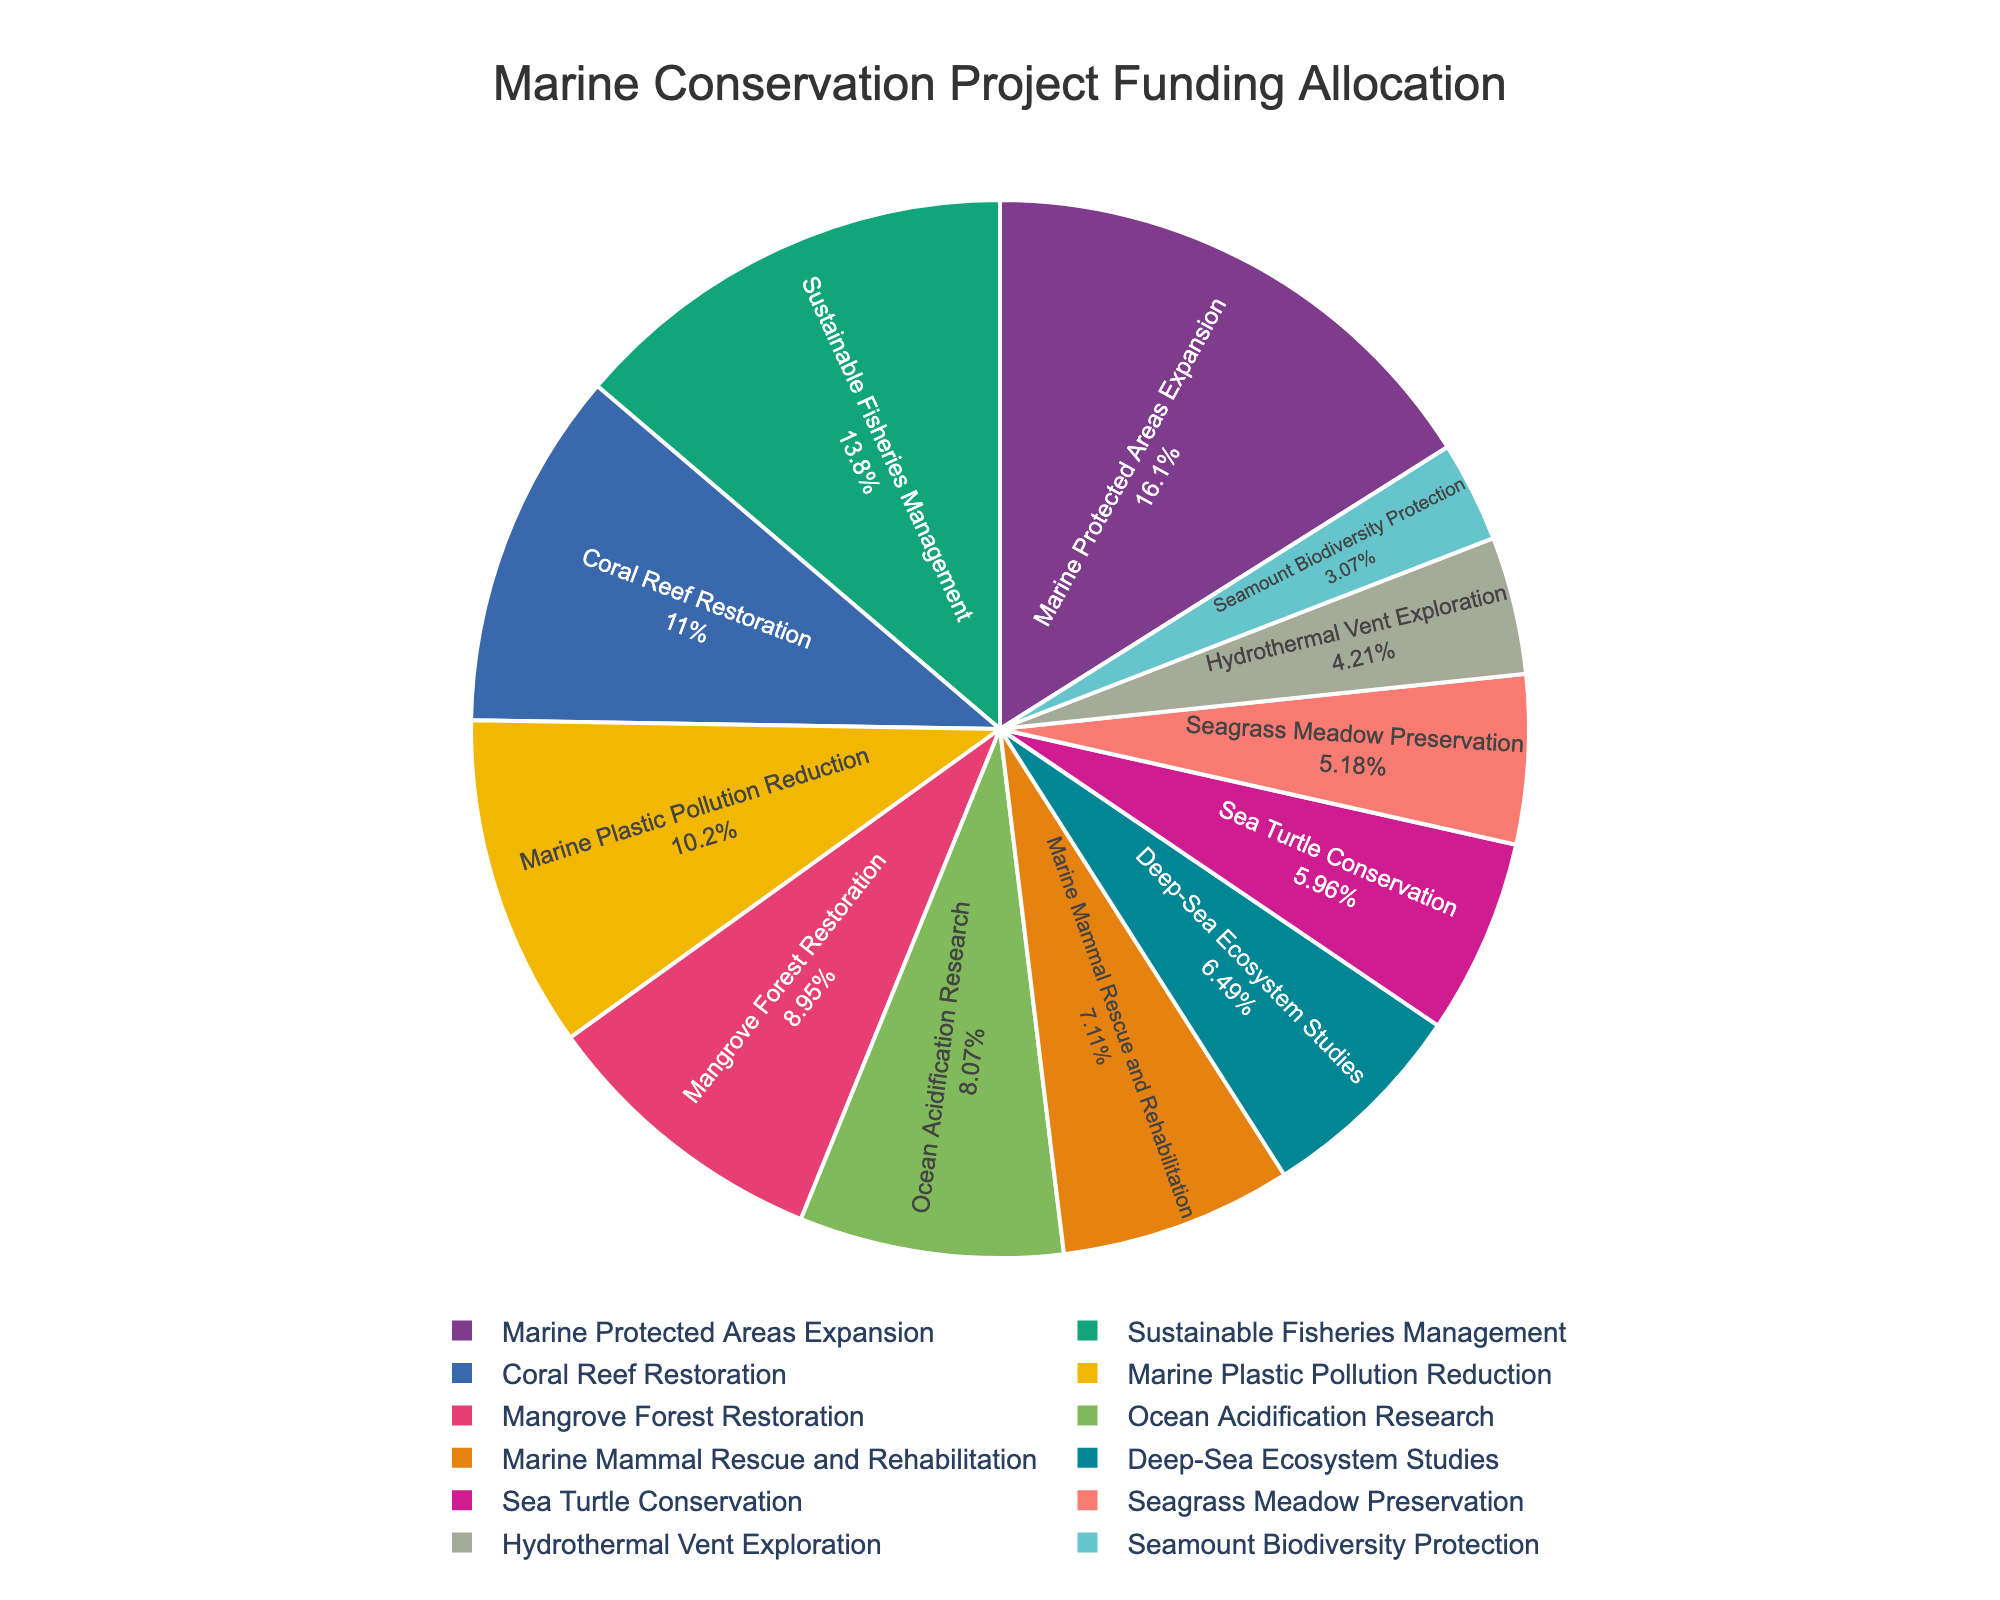Which project received the highest funding allocation? Scan through the figure and identify the project with the largest slice of the pie. This represents the highest percentage allocation.
Answer: Marine Protected Areas Expansion What is the difference in funding between Coral Reef Restoration and Seagrass Meadow Preservation? Locate the slices representing both "Coral Reef Restoration" and "Seagrass Meadow Preservation", note their funding amounts (12.5 and 5.9 million USD respectively), and subtract the smaller amount from the larger one.
Answer: 6.6 million USD Which project received less funding: Sea Turtle Conservation or Marine Mammal Rescue and Rehabilitation? Locate the slices representing both "Sea Turtle Conservation" and "Marine Mammal Rescue and Rehabilitation", then compare their funding values.
Answer: Sea Turtle Conservation What percentage of the total funding is allocated to Mangrove Forest Restoration and Marine Plastic Pollution Reduction combined? Identify the slices for "Mangrove Forest Restoration" and "Marine Plastic Pollution Reduction," note their funding values (10.2 and 11.6 million USD), sum these values (21.8 million USD), then calculate this sum as a percentage of the total funding.
Answer: 21.9% How does Ocean Acidification Research compare to Hydrothermal Vent Exploration in terms of funding allocation? Identify the slices for both "Ocean Acidification Research" and "Hydrothermal Vent Exploration," and then compare their funding values (9.2 and 4.8 million USD respectively).
Answer: Ocean Acidification Research received more funding Rank the top three projects by funding allocation. Scan through the pie chart and note the funding amounts for each project. Rank the projects from highest to lowest funding.
Answer: 1. Marine Protected Areas Expansion, 2. Sustainable Fisheries Management, 3. Coral Reef Restoration Is the funding for Deep-Sea Ecosystem Studies more or less than 10% of the total funding? Identify the slice for "Deep-Sea Ecosystem Studies" and check its percentage of the total funding allocation.
Answer: Less What is the combined funding of all projects related to fisheries and reefs? Identify the slices for "Sustainable Fisheries Management" and "Coral Reef Restoration," sum their funding values (15.7 and 12.5 million USD).
Answer: 28.2 million USD How does the combined funding for Seamount Biodiversity Protection and Hydrothermal Vents Exploration compare to that of Marine Mammal Rescue and Rehabilitation? Sum the funding values for "Seamount Biodiversity Protection" and "Hydrothermal Vents Exploration" (3.5 and 4.8 million USD), compare this sum (8.3 million USD) to the funding for "Marine Mammal Rescue and Rehabilitation" (8.1 million USD).
Answer: Slightly higher Which color represents the funding allocation for Ocean Acidification Research? Identify the pie slice for "Ocean Acidification Research" and note its color based on the visual representation.
Answer: (Assuming the answer based on typical color palette usage) Light blue or cyan 